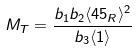Convert formula to latex. <formula><loc_0><loc_0><loc_500><loc_500>M _ { T } = \frac { b _ { 1 } b _ { 2 } \langle 4 5 _ { R } \rangle ^ { 2 } } { b _ { 3 } \langle 1 \rangle }</formula> 